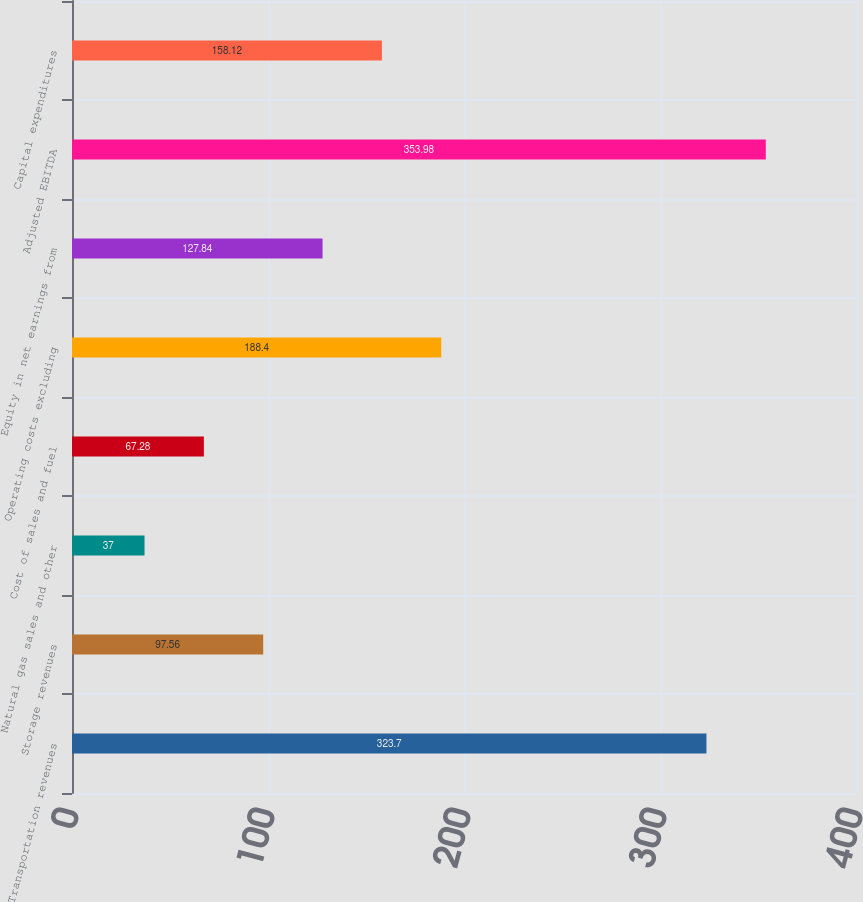Convert chart. <chart><loc_0><loc_0><loc_500><loc_500><bar_chart><fcel>Transportation revenues<fcel>Storage revenues<fcel>Natural gas sales and other<fcel>Cost of sales and fuel<fcel>Operating costs excluding<fcel>Equity in net earnings from<fcel>Adjusted EBITDA<fcel>Capital expenditures<nl><fcel>323.7<fcel>97.56<fcel>37<fcel>67.28<fcel>188.4<fcel>127.84<fcel>353.98<fcel>158.12<nl></chart> 